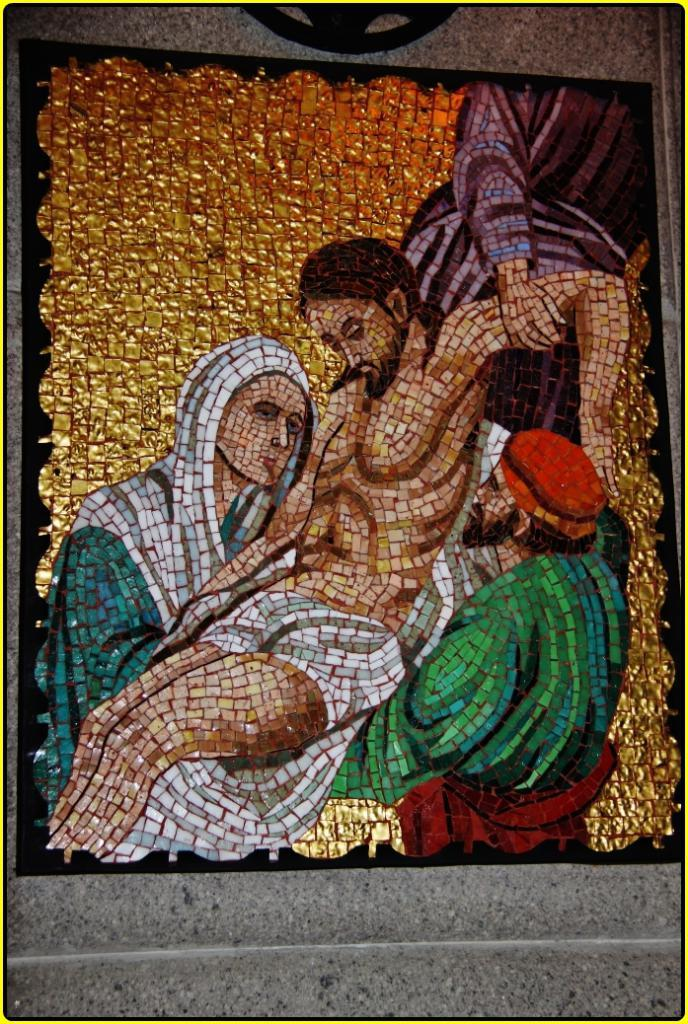What is the main subject in the center of the image? There is a photo frame in the center of the image. What is displayed within the photo frame? The photo frame contains a picture of some persons. What can be seen behind the photo frame in the image? There is a wall in the background of the image. Can you see any twigs growing out of the persons' heads in the picture? No, there are no twigs visible in the image. 